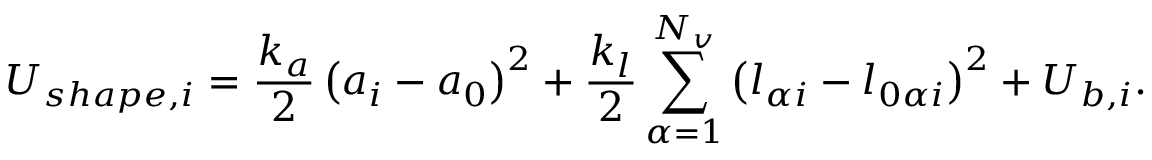<formula> <loc_0><loc_0><loc_500><loc_500>U _ { s h a p e , i } = \frac { k _ { a } } { 2 } \left ( a _ { i } - a _ { 0 } \right ) ^ { 2 } + \frac { k _ { l } } { 2 } \sum _ { \alpha = 1 } ^ { N _ { v } } \left ( l _ { \alpha i } - l _ { 0 \alpha i } \right ) ^ { 2 } + U _ { b , i } .</formula> 